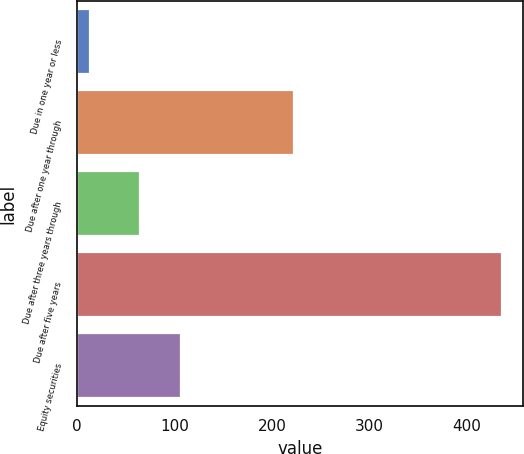Convert chart to OTSL. <chart><loc_0><loc_0><loc_500><loc_500><bar_chart><fcel>Due in one year or less<fcel>Due after one year through<fcel>Due after three years through<fcel>Due after five years<fcel>Equity securities<nl><fcel>13<fcel>222<fcel>64<fcel>436<fcel>106.3<nl></chart> 